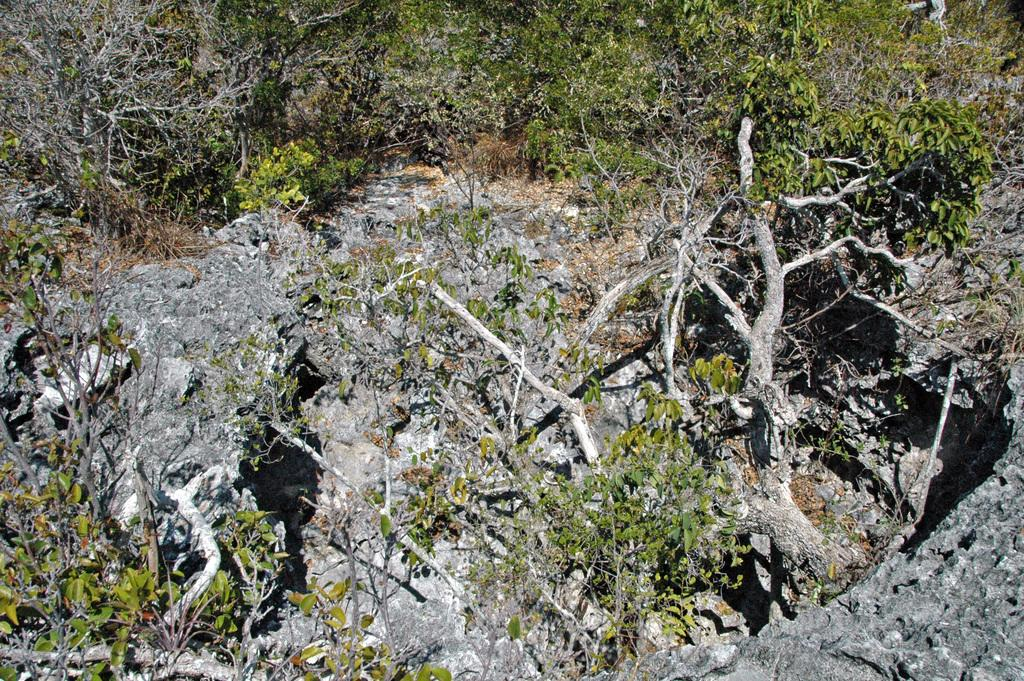What type of vegetation is visible in the front of the image? There are plants in the front of the image. What type of vegetation is visible in the background of the image? There are trees in the background of the image. Can you describe the setting of the image based on the vegetation? The image appears to be set in a natural environment with both plants and trees present. What idea does the partner have for washing the plants in the image? There is no partner or mention of washing plants in the image. 